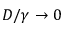Convert formula to latex. <formula><loc_0><loc_0><loc_500><loc_500>D / \gamma \to 0</formula> 